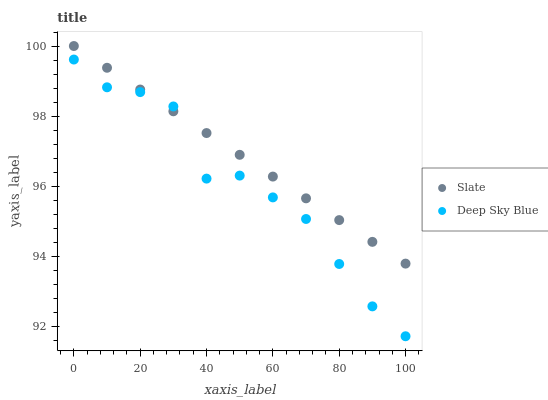Does Deep Sky Blue have the minimum area under the curve?
Answer yes or no. Yes. Does Slate have the maximum area under the curve?
Answer yes or no. Yes. Does Deep Sky Blue have the maximum area under the curve?
Answer yes or no. No. Is Slate the smoothest?
Answer yes or no. Yes. Is Deep Sky Blue the roughest?
Answer yes or no. Yes. Is Deep Sky Blue the smoothest?
Answer yes or no. No. Does Deep Sky Blue have the lowest value?
Answer yes or no. Yes. Does Slate have the highest value?
Answer yes or no. Yes. Does Deep Sky Blue have the highest value?
Answer yes or no. No. Does Deep Sky Blue intersect Slate?
Answer yes or no. Yes. Is Deep Sky Blue less than Slate?
Answer yes or no. No. Is Deep Sky Blue greater than Slate?
Answer yes or no. No. 